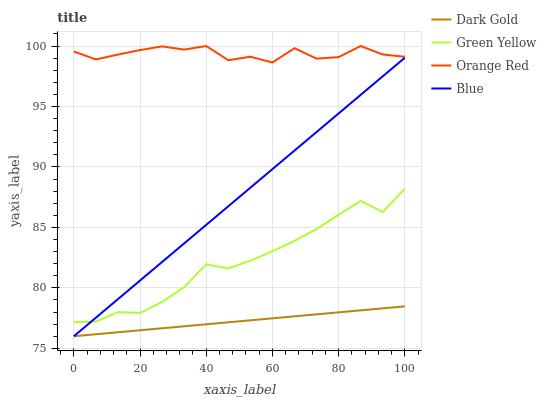Does Dark Gold have the minimum area under the curve?
Answer yes or no. Yes. Does Orange Red have the maximum area under the curve?
Answer yes or no. Yes. Does Green Yellow have the minimum area under the curve?
Answer yes or no. No. Does Green Yellow have the maximum area under the curve?
Answer yes or no. No. Is Dark Gold the smoothest?
Answer yes or no. Yes. Is Orange Red the roughest?
Answer yes or no. Yes. Is Green Yellow the smoothest?
Answer yes or no. No. Is Green Yellow the roughest?
Answer yes or no. No. Does Green Yellow have the lowest value?
Answer yes or no. No. Does Orange Red have the highest value?
Answer yes or no. Yes. Does Green Yellow have the highest value?
Answer yes or no. No. Is Blue less than Orange Red?
Answer yes or no. Yes. Is Orange Red greater than Dark Gold?
Answer yes or no. Yes. Does Blue intersect Orange Red?
Answer yes or no. No. 